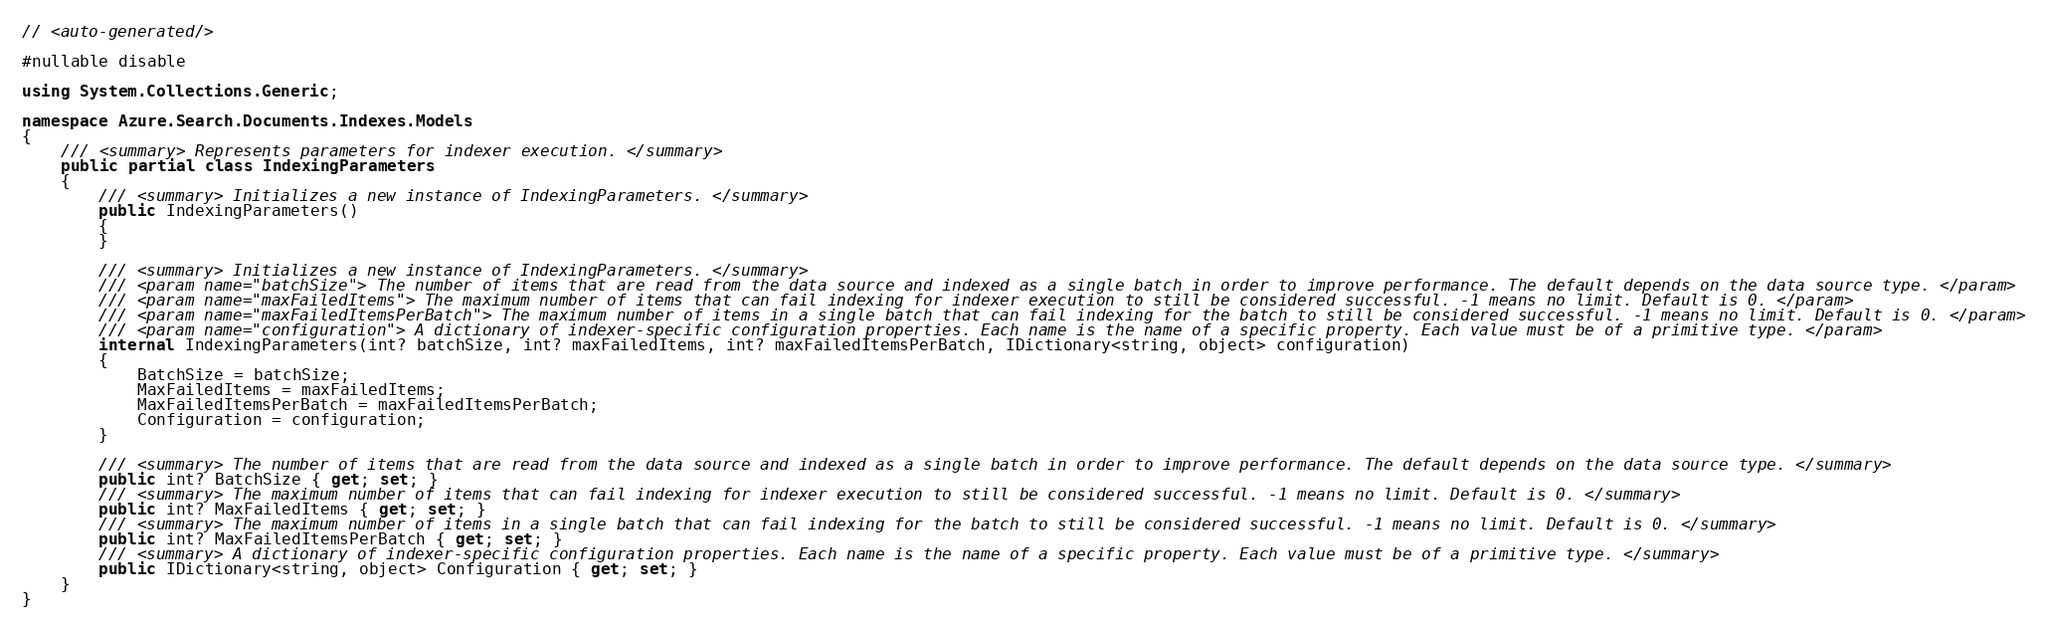<code> <loc_0><loc_0><loc_500><loc_500><_C#_>// <auto-generated/>

#nullable disable

using System.Collections.Generic;

namespace Azure.Search.Documents.Indexes.Models
{
    /// <summary> Represents parameters for indexer execution. </summary>
    public partial class IndexingParameters
    {
        /// <summary> Initializes a new instance of IndexingParameters. </summary>
        public IndexingParameters()
        {
        }

        /// <summary> Initializes a new instance of IndexingParameters. </summary>
        /// <param name="batchSize"> The number of items that are read from the data source and indexed as a single batch in order to improve performance. The default depends on the data source type. </param>
        /// <param name="maxFailedItems"> The maximum number of items that can fail indexing for indexer execution to still be considered successful. -1 means no limit. Default is 0. </param>
        /// <param name="maxFailedItemsPerBatch"> The maximum number of items in a single batch that can fail indexing for the batch to still be considered successful. -1 means no limit. Default is 0. </param>
        /// <param name="configuration"> A dictionary of indexer-specific configuration properties. Each name is the name of a specific property. Each value must be of a primitive type. </param>
        internal IndexingParameters(int? batchSize, int? maxFailedItems, int? maxFailedItemsPerBatch, IDictionary<string, object> configuration)
        {
            BatchSize = batchSize;
            MaxFailedItems = maxFailedItems;
            MaxFailedItemsPerBatch = maxFailedItemsPerBatch;
            Configuration = configuration;
        }

        /// <summary> The number of items that are read from the data source and indexed as a single batch in order to improve performance. The default depends on the data source type. </summary>
        public int? BatchSize { get; set; }
        /// <summary> The maximum number of items that can fail indexing for indexer execution to still be considered successful. -1 means no limit. Default is 0. </summary>
        public int? MaxFailedItems { get; set; }
        /// <summary> The maximum number of items in a single batch that can fail indexing for the batch to still be considered successful. -1 means no limit. Default is 0. </summary>
        public int? MaxFailedItemsPerBatch { get; set; }
        /// <summary> A dictionary of indexer-specific configuration properties. Each name is the name of a specific property. Each value must be of a primitive type. </summary>
        public IDictionary<string, object> Configuration { get; set; }
    }
}
</code> 